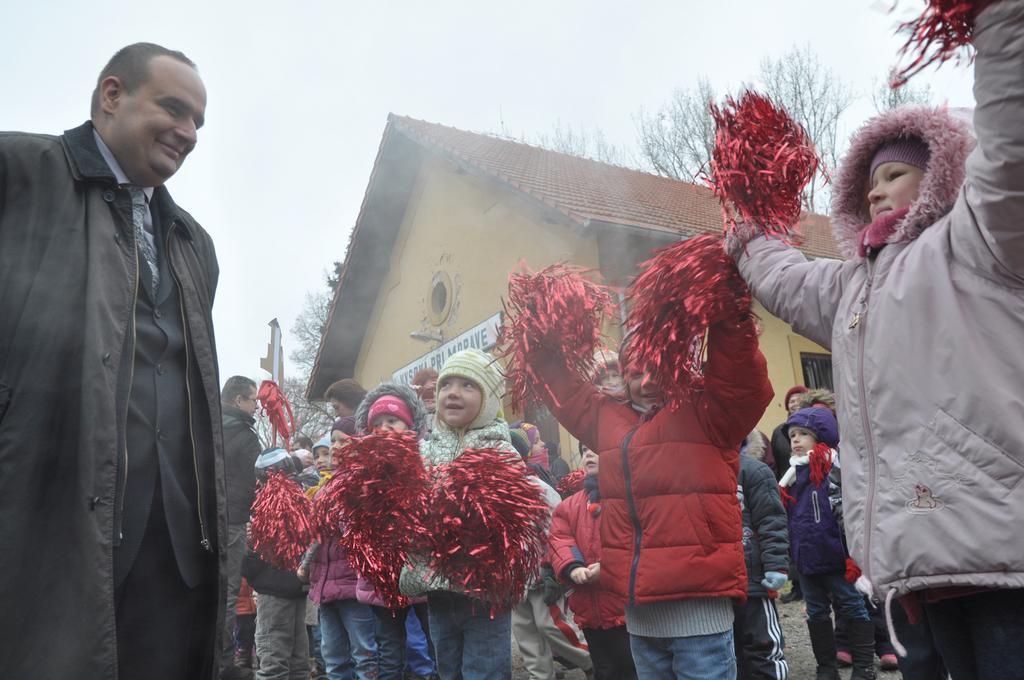In one or two sentences, can you explain what this image depicts? In this picture I can see a person with a smile on the left side. I can see a few children holding red color objects on the right side. I can see a few children on the right side. I can see the house. I can see trees in the background. I can see clouds in the sky. 